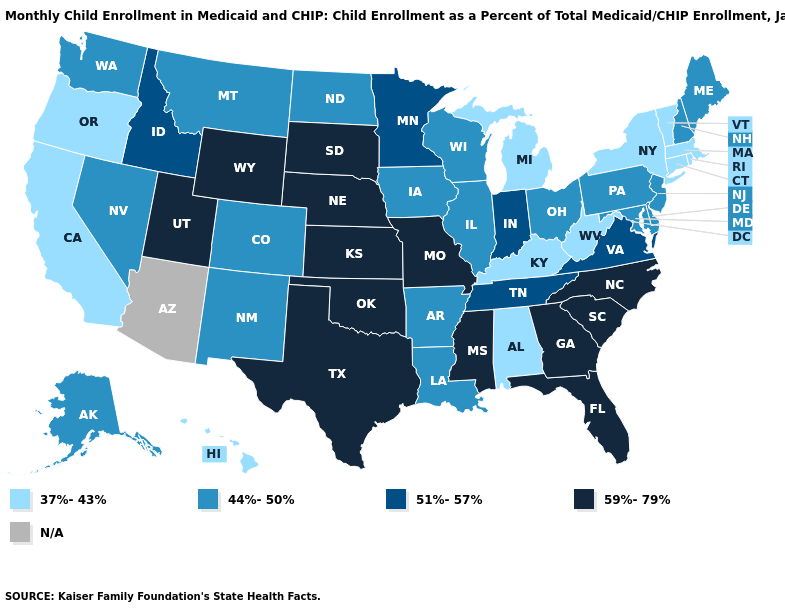What is the value of Arizona?
Give a very brief answer. N/A. Name the states that have a value in the range 51%-57%?
Short answer required. Idaho, Indiana, Minnesota, Tennessee, Virginia. Does Connecticut have the lowest value in the Northeast?
Give a very brief answer. Yes. Among the states that border Michigan , which have the lowest value?
Give a very brief answer. Ohio, Wisconsin. Does Washington have the lowest value in the West?
Write a very short answer. No. What is the value of Kansas?
Write a very short answer. 59%-79%. Which states have the lowest value in the USA?
Answer briefly. Alabama, California, Connecticut, Hawaii, Kentucky, Massachusetts, Michigan, New York, Oregon, Rhode Island, Vermont, West Virginia. What is the lowest value in the MidWest?
Answer briefly. 37%-43%. Among the states that border Maine , which have the lowest value?
Keep it brief. New Hampshire. Name the states that have a value in the range 59%-79%?
Concise answer only. Florida, Georgia, Kansas, Mississippi, Missouri, Nebraska, North Carolina, Oklahoma, South Carolina, South Dakota, Texas, Utah, Wyoming. What is the lowest value in the USA?
Quick response, please. 37%-43%. What is the value of Mississippi?
Give a very brief answer. 59%-79%. Among the states that border North Carolina , which have the lowest value?
Write a very short answer. Tennessee, Virginia. What is the value of Idaho?
Answer briefly. 51%-57%. 